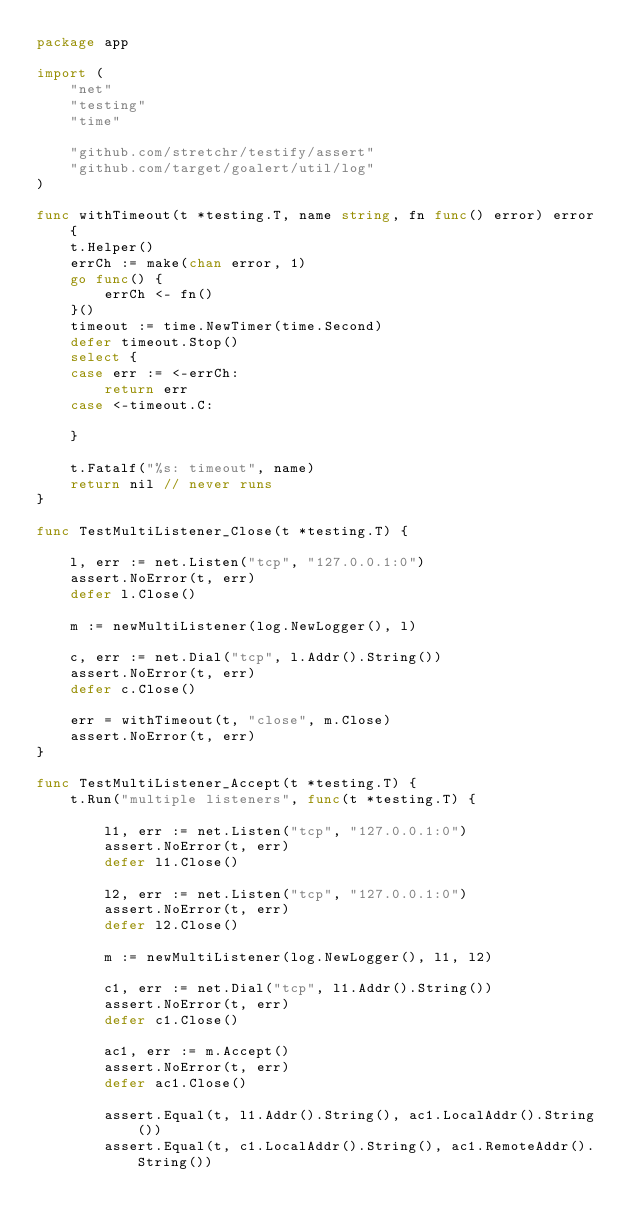Convert code to text. <code><loc_0><loc_0><loc_500><loc_500><_Go_>package app

import (
	"net"
	"testing"
	"time"

	"github.com/stretchr/testify/assert"
	"github.com/target/goalert/util/log"
)

func withTimeout(t *testing.T, name string, fn func() error) error {
	t.Helper()
	errCh := make(chan error, 1)
	go func() {
		errCh <- fn()
	}()
	timeout := time.NewTimer(time.Second)
	defer timeout.Stop()
	select {
	case err := <-errCh:
		return err
	case <-timeout.C:

	}

	t.Fatalf("%s: timeout", name)
	return nil // never runs
}

func TestMultiListener_Close(t *testing.T) {

	l, err := net.Listen("tcp", "127.0.0.1:0")
	assert.NoError(t, err)
	defer l.Close()

	m := newMultiListener(log.NewLogger(), l)

	c, err := net.Dial("tcp", l.Addr().String())
	assert.NoError(t, err)
	defer c.Close()

	err = withTimeout(t, "close", m.Close)
	assert.NoError(t, err)
}

func TestMultiListener_Accept(t *testing.T) {
	t.Run("multiple listeners", func(t *testing.T) {

		l1, err := net.Listen("tcp", "127.0.0.1:0")
		assert.NoError(t, err)
		defer l1.Close()

		l2, err := net.Listen("tcp", "127.0.0.1:0")
		assert.NoError(t, err)
		defer l2.Close()

		m := newMultiListener(log.NewLogger(), l1, l2)

		c1, err := net.Dial("tcp", l1.Addr().String())
		assert.NoError(t, err)
		defer c1.Close()

		ac1, err := m.Accept()
		assert.NoError(t, err)
		defer ac1.Close()

		assert.Equal(t, l1.Addr().String(), ac1.LocalAddr().String())
		assert.Equal(t, c1.LocalAddr().String(), ac1.RemoteAddr().String())
</code> 